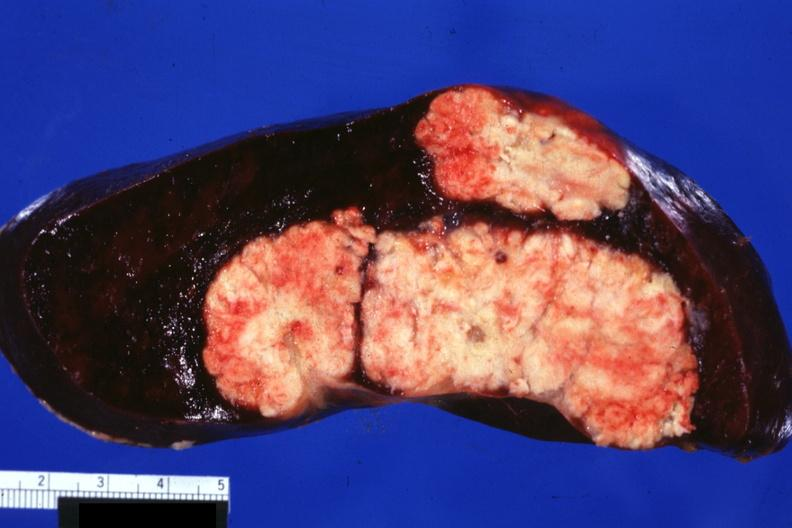s the excellent uterus present?
Answer the question using a single word or phrase. No 